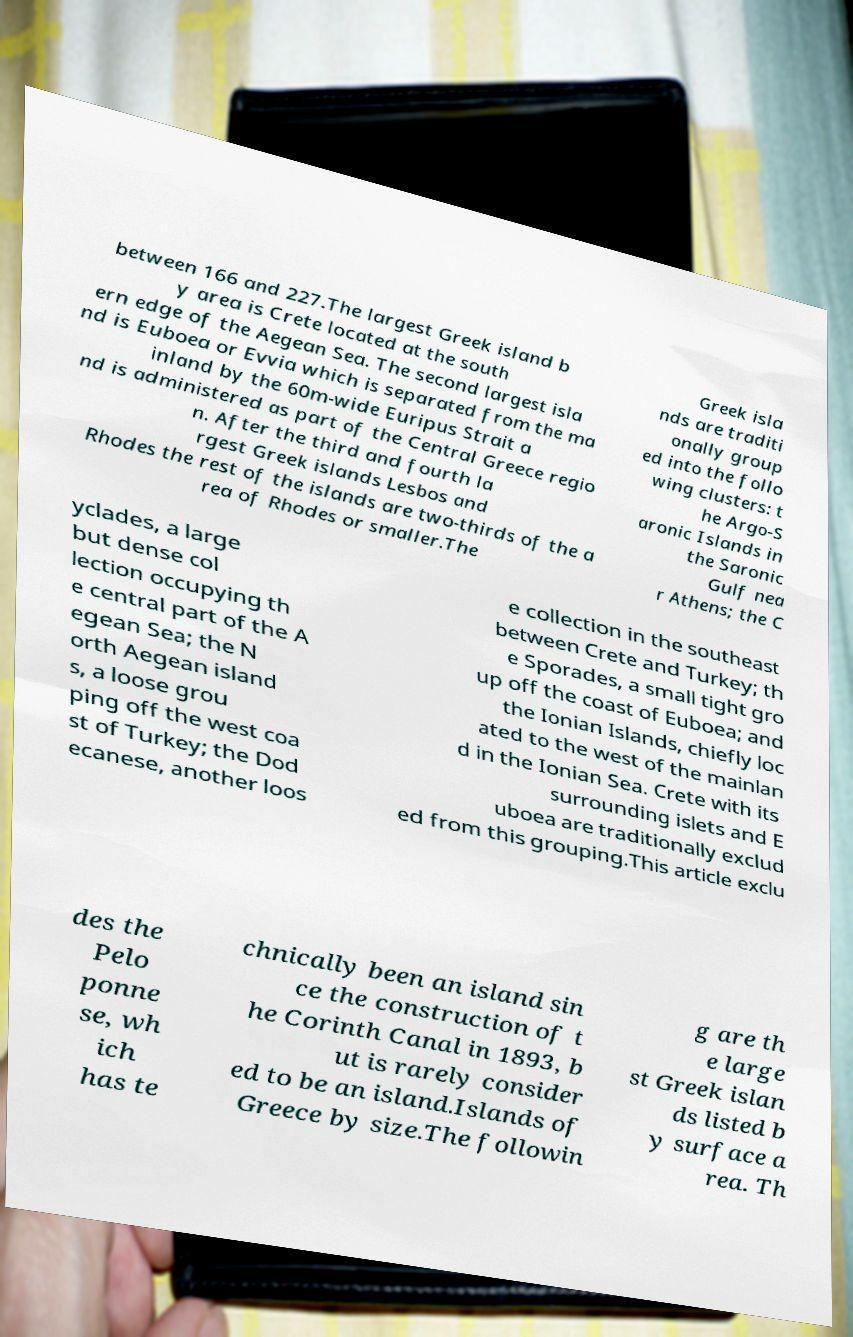I need the written content from this picture converted into text. Can you do that? between 166 and 227.The largest Greek island b y area is Crete located at the south ern edge of the Aegean Sea. The second largest isla nd is Euboea or Evvia which is separated from the ma inland by the 60m-wide Euripus Strait a nd is administered as part of the Central Greece regio n. After the third and fourth la rgest Greek islands Lesbos and Rhodes the rest of the islands are two-thirds of the a rea of Rhodes or smaller.The Greek isla nds are traditi onally group ed into the follo wing clusters: t he Argo-S aronic Islands in the Saronic Gulf nea r Athens; the C yclades, a large but dense col lection occupying th e central part of the A egean Sea; the N orth Aegean island s, a loose grou ping off the west coa st of Turkey; the Dod ecanese, another loos e collection in the southeast between Crete and Turkey; th e Sporades, a small tight gro up off the coast of Euboea; and the Ionian Islands, chiefly loc ated to the west of the mainlan d in the Ionian Sea. Crete with its surrounding islets and E uboea are traditionally exclud ed from this grouping.This article exclu des the Pelo ponne se, wh ich has te chnically been an island sin ce the construction of t he Corinth Canal in 1893, b ut is rarely consider ed to be an island.Islands of Greece by size.The followin g are th e large st Greek islan ds listed b y surface a rea. Th 